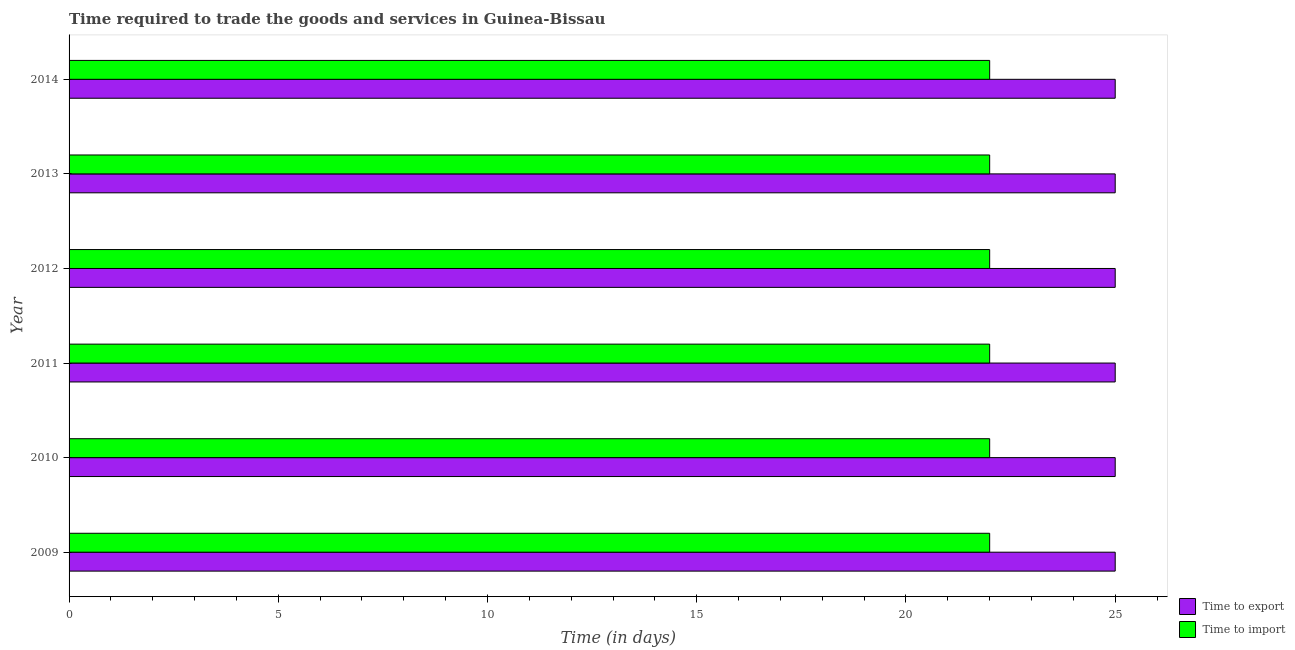How many groups of bars are there?
Provide a short and direct response. 6. Are the number of bars per tick equal to the number of legend labels?
Provide a short and direct response. Yes. How many bars are there on the 3rd tick from the top?
Your answer should be compact. 2. How many bars are there on the 1st tick from the bottom?
Your answer should be very brief. 2. What is the label of the 6th group of bars from the top?
Your answer should be compact. 2009. In how many cases, is the number of bars for a given year not equal to the number of legend labels?
Offer a very short reply. 0. What is the time to export in 2013?
Keep it short and to the point. 25. Across all years, what is the maximum time to export?
Your answer should be very brief. 25. Across all years, what is the minimum time to export?
Make the answer very short. 25. In which year was the time to export maximum?
Offer a very short reply. 2009. What is the total time to import in the graph?
Give a very brief answer. 132. What is the difference between the time to export in 2009 and that in 2012?
Offer a very short reply. 0. What is the difference between the time to export in 2011 and the time to import in 2012?
Your response must be concise. 3. What is the average time to export per year?
Ensure brevity in your answer.  25. In the year 2013, what is the difference between the time to export and time to import?
Provide a succinct answer. 3. In how many years, is the time to export greater than 23 days?
Give a very brief answer. 6. What is the difference between the highest and the lowest time to import?
Give a very brief answer. 0. Is the sum of the time to import in 2010 and 2013 greater than the maximum time to export across all years?
Your response must be concise. Yes. What does the 2nd bar from the top in 2010 represents?
Offer a very short reply. Time to export. What does the 2nd bar from the bottom in 2013 represents?
Your answer should be very brief. Time to import. How many bars are there?
Ensure brevity in your answer.  12. What is the difference between two consecutive major ticks on the X-axis?
Your response must be concise. 5. Are the values on the major ticks of X-axis written in scientific E-notation?
Provide a short and direct response. No. How many legend labels are there?
Your answer should be compact. 2. How are the legend labels stacked?
Provide a short and direct response. Vertical. What is the title of the graph?
Provide a short and direct response. Time required to trade the goods and services in Guinea-Bissau. Does "External balance on goods" appear as one of the legend labels in the graph?
Give a very brief answer. No. What is the label or title of the X-axis?
Provide a succinct answer. Time (in days). What is the label or title of the Y-axis?
Your answer should be very brief. Year. What is the Time (in days) in Time to export in 2009?
Your answer should be very brief. 25. What is the Time (in days) in Time to export in 2010?
Make the answer very short. 25. What is the Time (in days) in Time to export in 2011?
Offer a very short reply. 25. What is the Time (in days) in Time to export in 2012?
Offer a very short reply. 25. What is the Time (in days) of Time to import in 2013?
Your answer should be very brief. 22. What is the Time (in days) in Time to import in 2014?
Offer a very short reply. 22. Across all years, what is the maximum Time (in days) in Time to export?
Provide a short and direct response. 25. What is the total Time (in days) of Time to export in the graph?
Make the answer very short. 150. What is the total Time (in days) in Time to import in the graph?
Your answer should be very brief. 132. What is the difference between the Time (in days) in Time to export in 2009 and that in 2010?
Provide a short and direct response. 0. What is the difference between the Time (in days) in Time to import in 2009 and that in 2010?
Offer a very short reply. 0. What is the difference between the Time (in days) in Time to import in 2009 and that in 2011?
Provide a succinct answer. 0. What is the difference between the Time (in days) in Time to import in 2009 and that in 2012?
Provide a succinct answer. 0. What is the difference between the Time (in days) in Time to export in 2009 and that in 2013?
Offer a terse response. 0. What is the difference between the Time (in days) of Time to import in 2009 and that in 2013?
Your answer should be very brief. 0. What is the difference between the Time (in days) of Time to import in 2009 and that in 2014?
Make the answer very short. 0. What is the difference between the Time (in days) in Time to export in 2010 and that in 2011?
Ensure brevity in your answer.  0. What is the difference between the Time (in days) of Time to import in 2010 and that in 2012?
Provide a succinct answer. 0. What is the difference between the Time (in days) in Time to export in 2010 and that in 2013?
Offer a very short reply. 0. What is the difference between the Time (in days) in Time to import in 2010 and that in 2013?
Your answer should be very brief. 0. What is the difference between the Time (in days) in Time to export in 2010 and that in 2014?
Keep it short and to the point. 0. What is the difference between the Time (in days) of Time to import in 2010 and that in 2014?
Your response must be concise. 0. What is the difference between the Time (in days) of Time to export in 2011 and that in 2013?
Your answer should be very brief. 0. What is the difference between the Time (in days) of Time to import in 2011 and that in 2013?
Provide a short and direct response. 0. What is the difference between the Time (in days) in Time to export in 2011 and that in 2014?
Provide a short and direct response. 0. What is the difference between the Time (in days) in Time to import in 2011 and that in 2014?
Offer a very short reply. 0. What is the difference between the Time (in days) of Time to export in 2012 and that in 2014?
Give a very brief answer. 0. What is the difference between the Time (in days) of Time to export in 2013 and that in 2014?
Give a very brief answer. 0. What is the difference between the Time (in days) in Time to export in 2009 and the Time (in days) in Time to import in 2010?
Your response must be concise. 3. What is the difference between the Time (in days) of Time to export in 2009 and the Time (in days) of Time to import in 2011?
Offer a terse response. 3. What is the difference between the Time (in days) of Time to export in 2010 and the Time (in days) of Time to import in 2012?
Your answer should be very brief. 3. What is the difference between the Time (in days) in Time to export in 2010 and the Time (in days) in Time to import in 2013?
Provide a short and direct response. 3. What is the difference between the Time (in days) in Time to export in 2010 and the Time (in days) in Time to import in 2014?
Your answer should be compact. 3. What is the difference between the Time (in days) of Time to export in 2011 and the Time (in days) of Time to import in 2012?
Keep it short and to the point. 3. What is the difference between the Time (in days) of Time to export in 2011 and the Time (in days) of Time to import in 2013?
Keep it short and to the point. 3. What is the average Time (in days) of Time to import per year?
Provide a succinct answer. 22. In the year 2010, what is the difference between the Time (in days) in Time to export and Time (in days) in Time to import?
Give a very brief answer. 3. In the year 2011, what is the difference between the Time (in days) of Time to export and Time (in days) of Time to import?
Ensure brevity in your answer.  3. In the year 2013, what is the difference between the Time (in days) of Time to export and Time (in days) of Time to import?
Give a very brief answer. 3. What is the ratio of the Time (in days) of Time to export in 2009 to that in 2010?
Offer a terse response. 1. What is the ratio of the Time (in days) in Time to import in 2009 to that in 2010?
Provide a succinct answer. 1. What is the ratio of the Time (in days) in Time to export in 2009 to that in 2013?
Make the answer very short. 1. What is the ratio of the Time (in days) of Time to export in 2009 to that in 2014?
Provide a short and direct response. 1. What is the ratio of the Time (in days) of Time to export in 2010 to that in 2012?
Keep it short and to the point. 1. What is the ratio of the Time (in days) in Time to export in 2010 to that in 2013?
Ensure brevity in your answer.  1. What is the ratio of the Time (in days) in Time to import in 2010 to that in 2014?
Your response must be concise. 1. What is the ratio of the Time (in days) of Time to import in 2011 to that in 2012?
Ensure brevity in your answer.  1. What is the ratio of the Time (in days) of Time to import in 2011 to that in 2013?
Your answer should be compact. 1. What is the ratio of the Time (in days) in Time to export in 2011 to that in 2014?
Offer a very short reply. 1. What is the ratio of the Time (in days) in Time to import in 2011 to that in 2014?
Keep it short and to the point. 1. What is the ratio of the Time (in days) in Time to export in 2012 to that in 2013?
Provide a short and direct response. 1. What is the ratio of the Time (in days) of Time to import in 2012 to that in 2014?
Keep it short and to the point. 1. What is the difference between the highest and the second highest Time (in days) in Time to export?
Provide a succinct answer. 0. What is the difference between the highest and the second highest Time (in days) of Time to import?
Offer a terse response. 0. 